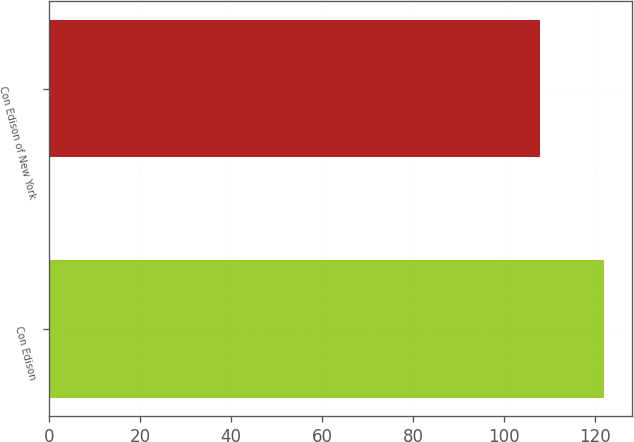<chart> <loc_0><loc_0><loc_500><loc_500><bar_chart><fcel>Con Edison<fcel>Con Edison of New York<nl><fcel>122<fcel>108<nl></chart> 